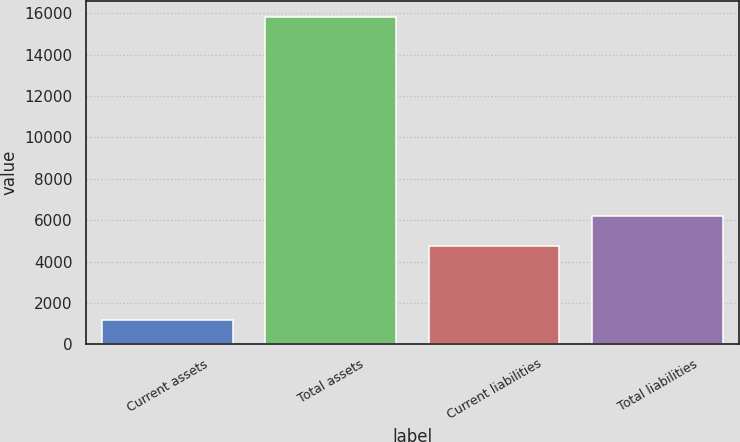Convert chart. <chart><loc_0><loc_0><loc_500><loc_500><bar_chart><fcel>Current assets<fcel>Total assets<fcel>Current liabilities<fcel>Total liabilities<nl><fcel>1172<fcel>15802<fcel>4748<fcel>6211<nl></chart> 